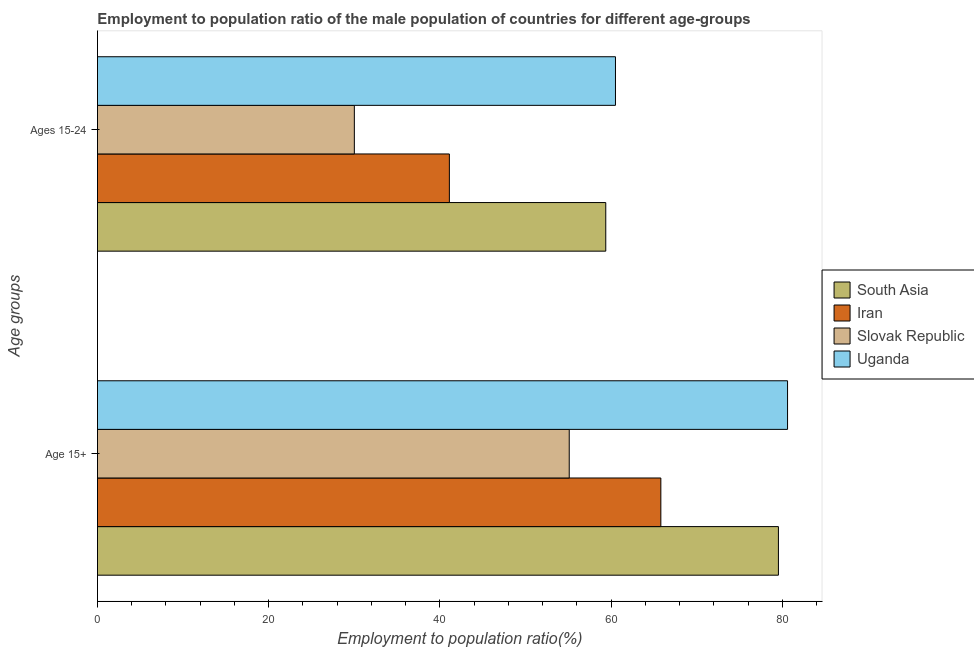How many different coloured bars are there?
Offer a terse response. 4. How many groups of bars are there?
Make the answer very short. 2. Are the number of bars on each tick of the Y-axis equal?
Your response must be concise. Yes. What is the label of the 1st group of bars from the top?
Your answer should be very brief. Ages 15-24. What is the employment to population ratio(age 15-24) in South Asia?
Offer a very short reply. 59.37. Across all countries, what is the maximum employment to population ratio(age 15+)?
Your answer should be very brief. 80.6. In which country was the employment to population ratio(age 15+) maximum?
Ensure brevity in your answer.  Uganda. In which country was the employment to population ratio(age 15-24) minimum?
Make the answer very short. Slovak Republic. What is the total employment to population ratio(age 15-24) in the graph?
Give a very brief answer. 190.97. What is the difference between the employment to population ratio(age 15+) in Slovak Republic and that in Iran?
Your answer should be very brief. -10.7. What is the difference between the employment to population ratio(age 15+) in South Asia and the employment to population ratio(age 15-24) in Iran?
Ensure brevity in your answer.  38.43. What is the average employment to population ratio(age 15-24) per country?
Keep it short and to the point. 47.74. What is the difference between the employment to population ratio(age 15+) and employment to population ratio(age 15-24) in South Asia?
Offer a terse response. 20.17. In how many countries, is the employment to population ratio(age 15+) greater than 80 %?
Your answer should be very brief. 1. What is the ratio of the employment to population ratio(age 15+) in Uganda to that in Slovak Republic?
Ensure brevity in your answer.  1.46. Is the employment to population ratio(age 15-24) in Slovak Republic less than that in Uganda?
Offer a terse response. Yes. What does the 2nd bar from the top in Ages 15-24 represents?
Ensure brevity in your answer.  Slovak Republic. What does the 3rd bar from the bottom in Age 15+ represents?
Provide a succinct answer. Slovak Republic. How many bars are there?
Keep it short and to the point. 8. Are all the bars in the graph horizontal?
Make the answer very short. Yes. What is the difference between two consecutive major ticks on the X-axis?
Give a very brief answer. 20. Does the graph contain any zero values?
Make the answer very short. No. How are the legend labels stacked?
Provide a short and direct response. Vertical. What is the title of the graph?
Offer a terse response. Employment to population ratio of the male population of countries for different age-groups. Does "South Africa" appear as one of the legend labels in the graph?
Give a very brief answer. No. What is the label or title of the X-axis?
Provide a short and direct response. Employment to population ratio(%). What is the label or title of the Y-axis?
Give a very brief answer. Age groups. What is the Employment to population ratio(%) of South Asia in Age 15+?
Offer a very short reply. 79.53. What is the Employment to population ratio(%) in Iran in Age 15+?
Offer a very short reply. 65.8. What is the Employment to population ratio(%) of Slovak Republic in Age 15+?
Offer a terse response. 55.1. What is the Employment to population ratio(%) in Uganda in Age 15+?
Keep it short and to the point. 80.6. What is the Employment to population ratio(%) of South Asia in Ages 15-24?
Provide a succinct answer. 59.37. What is the Employment to population ratio(%) of Iran in Ages 15-24?
Offer a terse response. 41.1. What is the Employment to population ratio(%) of Uganda in Ages 15-24?
Keep it short and to the point. 60.5. Across all Age groups, what is the maximum Employment to population ratio(%) in South Asia?
Your response must be concise. 79.53. Across all Age groups, what is the maximum Employment to population ratio(%) of Iran?
Make the answer very short. 65.8. Across all Age groups, what is the maximum Employment to population ratio(%) of Slovak Republic?
Provide a succinct answer. 55.1. Across all Age groups, what is the maximum Employment to population ratio(%) in Uganda?
Provide a short and direct response. 80.6. Across all Age groups, what is the minimum Employment to population ratio(%) in South Asia?
Ensure brevity in your answer.  59.37. Across all Age groups, what is the minimum Employment to population ratio(%) in Iran?
Your answer should be very brief. 41.1. Across all Age groups, what is the minimum Employment to population ratio(%) of Uganda?
Your response must be concise. 60.5. What is the total Employment to population ratio(%) of South Asia in the graph?
Make the answer very short. 138.9. What is the total Employment to population ratio(%) in Iran in the graph?
Provide a short and direct response. 106.9. What is the total Employment to population ratio(%) of Slovak Republic in the graph?
Ensure brevity in your answer.  85.1. What is the total Employment to population ratio(%) in Uganda in the graph?
Ensure brevity in your answer.  141.1. What is the difference between the Employment to population ratio(%) of South Asia in Age 15+ and that in Ages 15-24?
Your answer should be compact. 20.17. What is the difference between the Employment to population ratio(%) of Iran in Age 15+ and that in Ages 15-24?
Provide a succinct answer. 24.7. What is the difference between the Employment to population ratio(%) of Slovak Republic in Age 15+ and that in Ages 15-24?
Ensure brevity in your answer.  25.1. What is the difference between the Employment to population ratio(%) in Uganda in Age 15+ and that in Ages 15-24?
Give a very brief answer. 20.1. What is the difference between the Employment to population ratio(%) in South Asia in Age 15+ and the Employment to population ratio(%) in Iran in Ages 15-24?
Provide a short and direct response. 38.43. What is the difference between the Employment to population ratio(%) of South Asia in Age 15+ and the Employment to population ratio(%) of Slovak Republic in Ages 15-24?
Make the answer very short. 49.53. What is the difference between the Employment to population ratio(%) in South Asia in Age 15+ and the Employment to population ratio(%) in Uganda in Ages 15-24?
Ensure brevity in your answer.  19.03. What is the difference between the Employment to population ratio(%) in Iran in Age 15+ and the Employment to population ratio(%) in Slovak Republic in Ages 15-24?
Provide a succinct answer. 35.8. What is the difference between the Employment to population ratio(%) of Iran in Age 15+ and the Employment to population ratio(%) of Uganda in Ages 15-24?
Offer a terse response. 5.3. What is the difference between the Employment to population ratio(%) of Slovak Republic in Age 15+ and the Employment to population ratio(%) of Uganda in Ages 15-24?
Your answer should be compact. -5.4. What is the average Employment to population ratio(%) in South Asia per Age groups?
Offer a very short reply. 69.45. What is the average Employment to population ratio(%) in Iran per Age groups?
Your answer should be very brief. 53.45. What is the average Employment to population ratio(%) in Slovak Republic per Age groups?
Give a very brief answer. 42.55. What is the average Employment to population ratio(%) of Uganda per Age groups?
Your response must be concise. 70.55. What is the difference between the Employment to population ratio(%) of South Asia and Employment to population ratio(%) of Iran in Age 15+?
Provide a succinct answer. 13.73. What is the difference between the Employment to population ratio(%) of South Asia and Employment to population ratio(%) of Slovak Republic in Age 15+?
Ensure brevity in your answer.  24.43. What is the difference between the Employment to population ratio(%) of South Asia and Employment to population ratio(%) of Uganda in Age 15+?
Make the answer very short. -1.07. What is the difference between the Employment to population ratio(%) in Iran and Employment to population ratio(%) in Slovak Republic in Age 15+?
Ensure brevity in your answer.  10.7. What is the difference between the Employment to population ratio(%) in Iran and Employment to population ratio(%) in Uganda in Age 15+?
Provide a succinct answer. -14.8. What is the difference between the Employment to population ratio(%) of Slovak Republic and Employment to population ratio(%) of Uganda in Age 15+?
Offer a terse response. -25.5. What is the difference between the Employment to population ratio(%) in South Asia and Employment to population ratio(%) in Iran in Ages 15-24?
Give a very brief answer. 18.27. What is the difference between the Employment to population ratio(%) in South Asia and Employment to population ratio(%) in Slovak Republic in Ages 15-24?
Your response must be concise. 29.37. What is the difference between the Employment to population ratio(%) in South Asia and Employment to population ratio(%) in Uganda in Ages 15-24?
Offer a terse response. -1.13. What is the difference between the Employment to population ratio(%) in Iran and Employment to population ratio(%) in Uganda in Ages 15-24?
Provide a short and direct response. -19.4. What is the difference between the Employment to population ratio(%) of Slovak Republic and Employment to population ratio(%) of Uganda in Ages 15-24?
Give a very brief answer. -30.5. What is the ratio of the Employment to population ratio(%) in South Asia in Age 15+ to that in Ages 15-24?
Make the answer very short. 1.34. What is the ratio of the Employment to population ratio(%) in Iran in Age 15+ to that in Ages 15-24?
Ensure brevity in your answer.  1.6. What is the ratio of the Employment to population ratio(%) in Slovak Republic in Age 15+ to that in Ages 15-24?
Ensure brevity in your answer.  1.84. What is the ratio of the Employment to population ratio(%) in Uganda in Age 15+ to that in Ages 15-24?
Keep it short and to the point. 1.33. What is the difference between the highest and the second highest Employment to population ratio(%) of South Asia?
Offer a terse response. 20.17. What is the difference between the highest and the second highest Employment to population ratio(%) in Iran?
Keep it short and to the point. 24.7. What is the difference between the highest and the second highest Employment to population ratio(%) of Slovak Republic?
Your answer should be very brief. 25.1. What is the difference between the highest and the second highest Employment to population ratio(%) of Uganda?
Offer a very short reply. 20.1. What is the difference between the highest and the lowest Employment to population ratio(%) in South Asia?
Offer a terse response. 20.17. What is the difference between the highest and the lowest Employment to population ratio(%) of Iran?
Keep it short and to the point. 24.7. What is the difference between the highest and the lowest Employment to population ratio(%) in Slovak Republic?
Your response must be concise. 25.1. What is the difference between the highest and the lowest Employment to population ratio(%) of Uganda?
Your answer should be very brief. 20.1. 